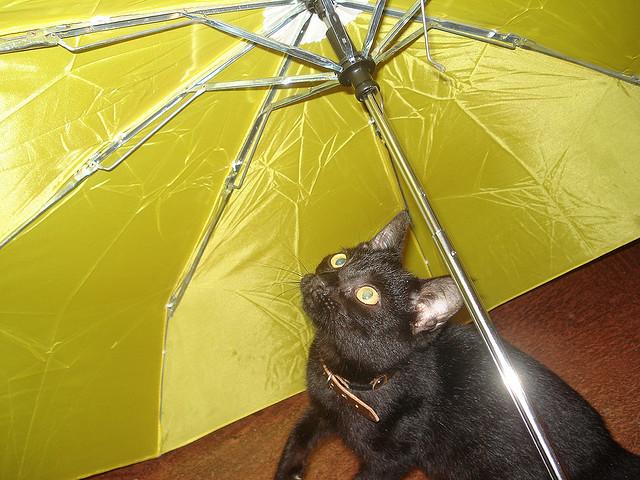Is this a spotlight umbrella?
Write a very short answer. No. Is there a collar in the picture?
Be succinct. Yes. Is the cat holding the umbrella?
Write a very short answer. No. 